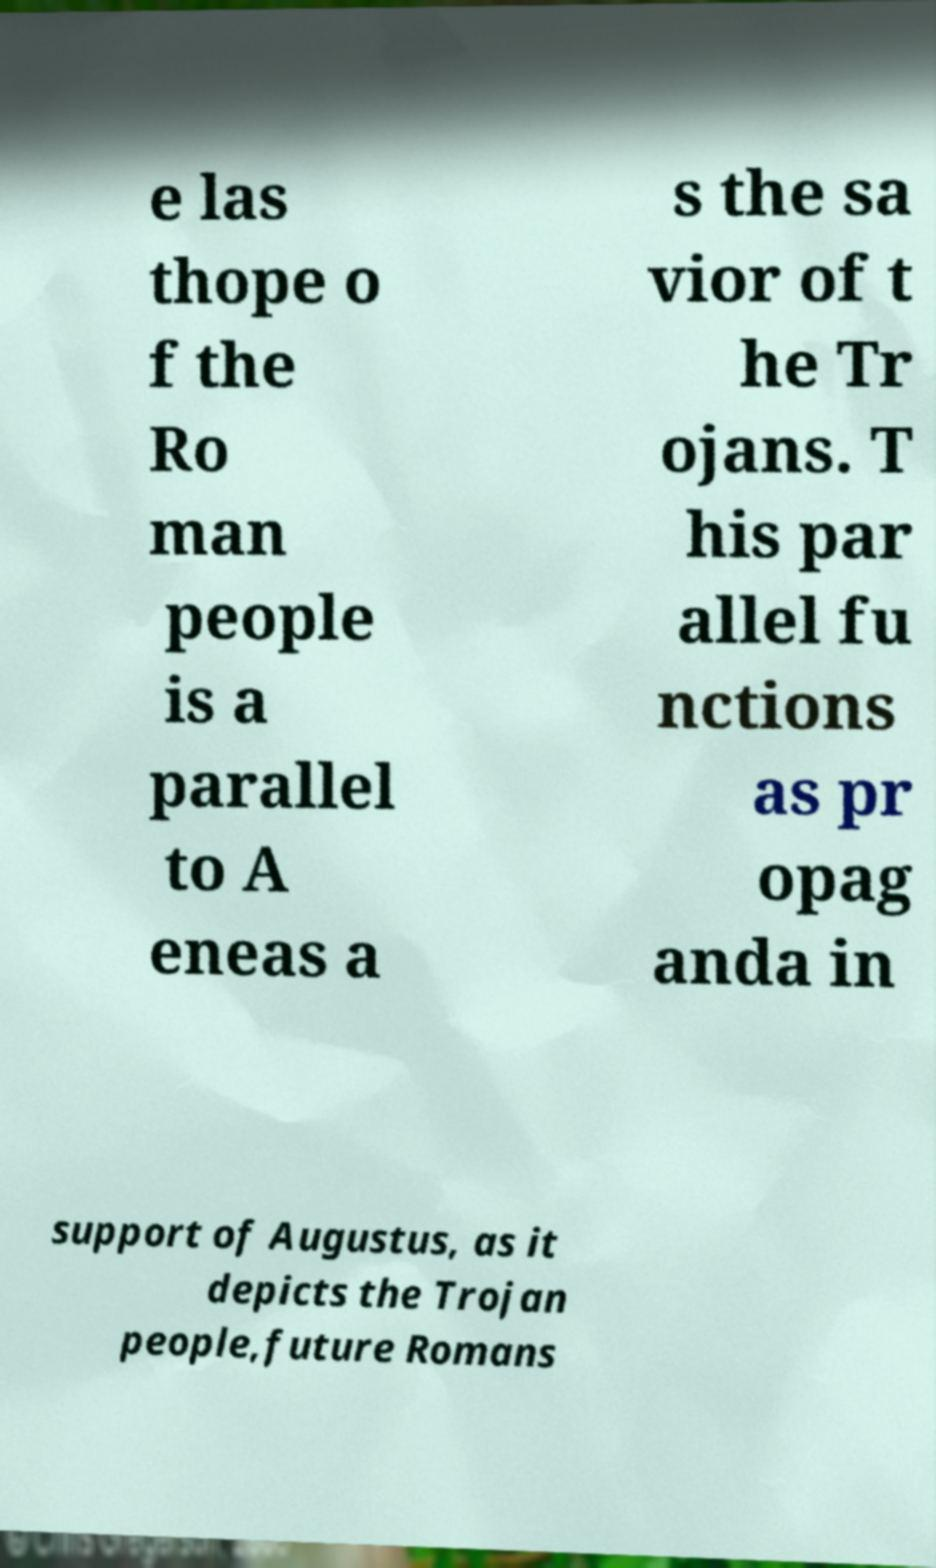For documentation purposes, I need the text within this image transcribed. Could you provide that? e las thope o f the Ro man people is a parallel to A eneas a s the sa vior of t he Tr ojans. T his par allel fu nctions as pr opag anda in support of Augustus, as it depicts the Trojan people,future Romans 